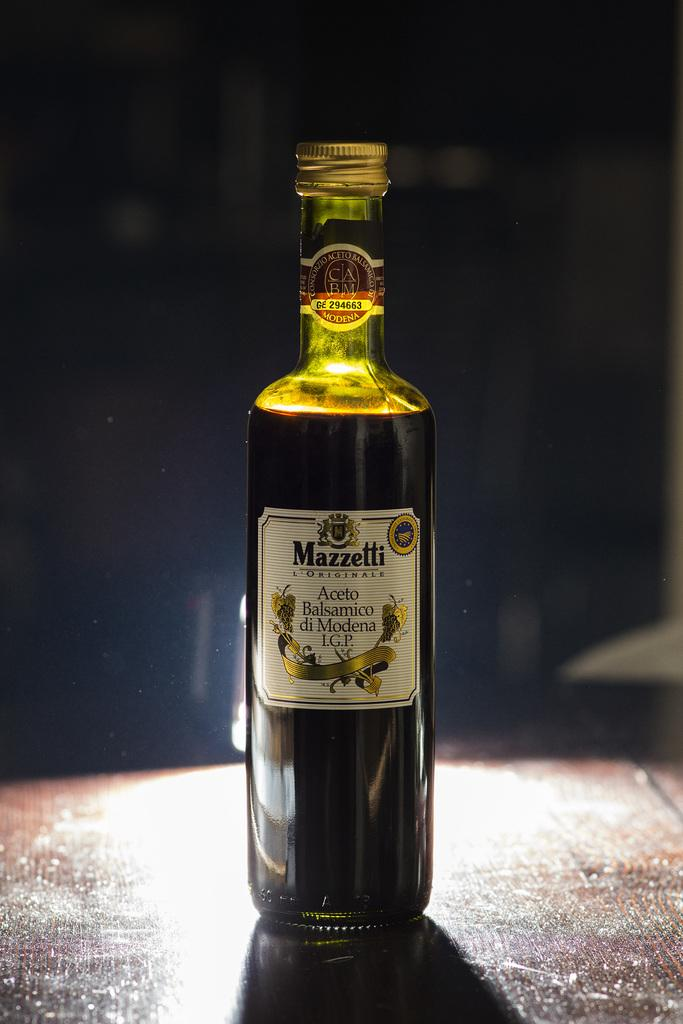What object is present in the image? There is a bottle in the image. What is inside the bottle? The bottle contains liquid. Where is the bottle located? The bottle is placed on a table. What type of plantation is visible in the image? There is no plantation present in the image; it only features a bottle containing liquid and placed on a table. 